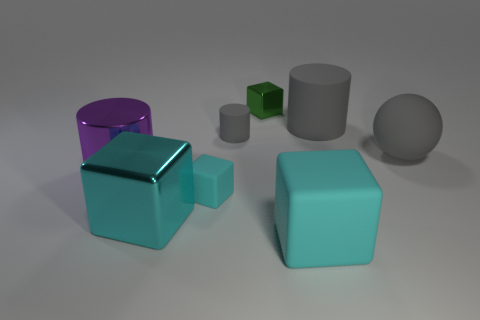Subtract all green shiny cubes. How many cubes are left? 3 Subtract all gray cylinders. How many cylinders are left? 1 Subtract 1 spheres. How many spheres are left? 0 Add 1 large gray rubber cylinders. How many objects exist? 9 Add 5 big purple metal things. How many big purple metal things exist? 6 Subtract 0 blue blocks. How many objects are left? 8 Subtract all spheres. How many objects are left? 7 Subtract all yellow cylinders. Subtract all cyan balls. How many cylinders are left? 3 Subtract all brown cylinders. How many purple blocks are left? 0 Subtract all tiny cyan spheres. Subtract all large gray rubber things. How many objects are left? 6 